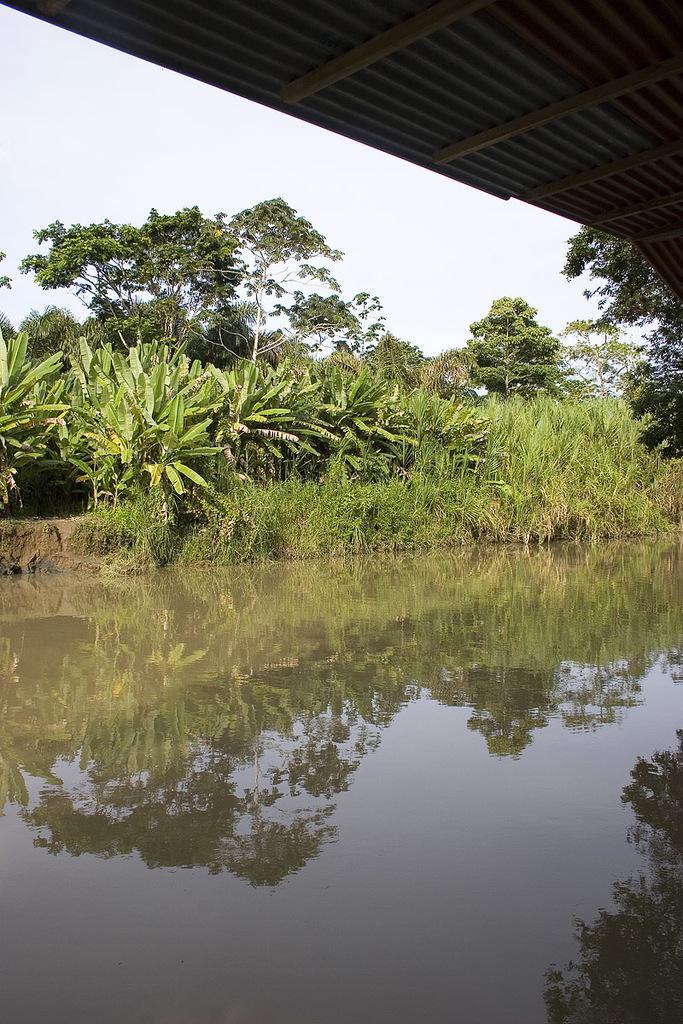In one or two sentences, can you explain what this image depicts? At the bottom of the picture, we see water and this water might be in the pond. In the middle, we see the grass and the trees. We see the reflections of trees in the water. In the background, we see the sky. At the top, we see the roof of the building. 